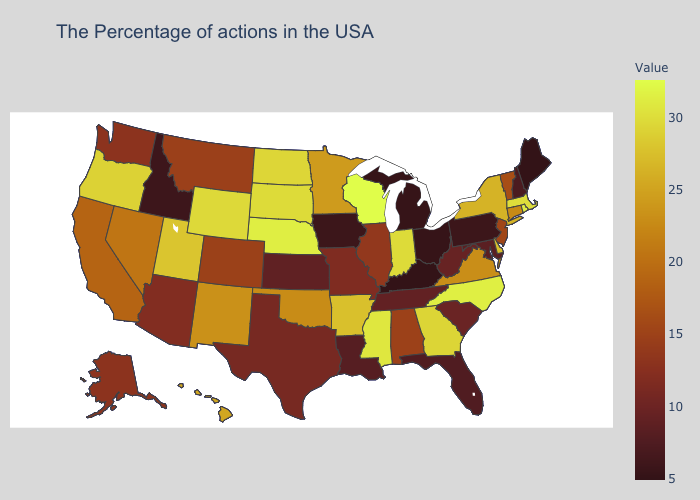Does Maine have the lowest value in the USA?
Keep it brief. Yes. Which states have the lowest value in the USA?
Short answer required. Maine, Kentucky. Which states have the lowest value in the Northeast?
Short answer required. Maine. Does Massachusetts have the lowest value in the Northeast?
Write a very short answer. No. Which states have the highest value in the USA?
Be succinct. Wisconsin. 